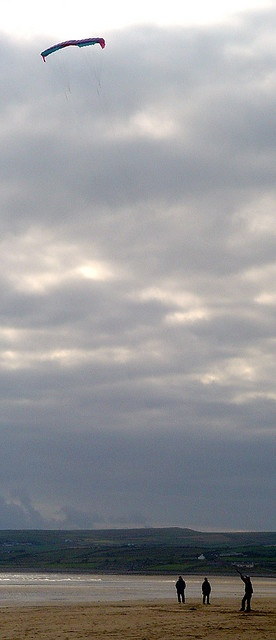Describe the objects in this image and their specific colors. I can see kite in white, teal, navy, black, and purple tones, people in white, black, gray, and darkgreen tones, people in white, black, and gray tones, and people in white, black, and gray tones in this image. 